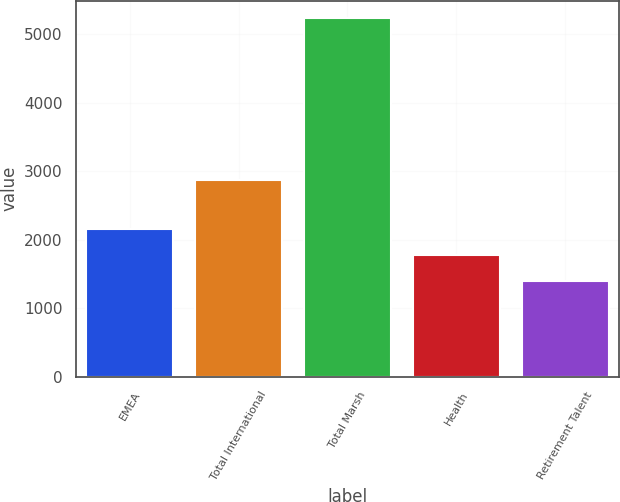<chart> <loc_0><loc_0><loc_500><loc_500><bar_chart><fcel>EMEA<fcel>Total International<fcel>Total Marsh<fcel>Health<fcel>Retirement Talent<nl><fcel>2163.2<fcel>2869<fcel>5232<fcel>1779.6<fcel>1396<nl></chart> 